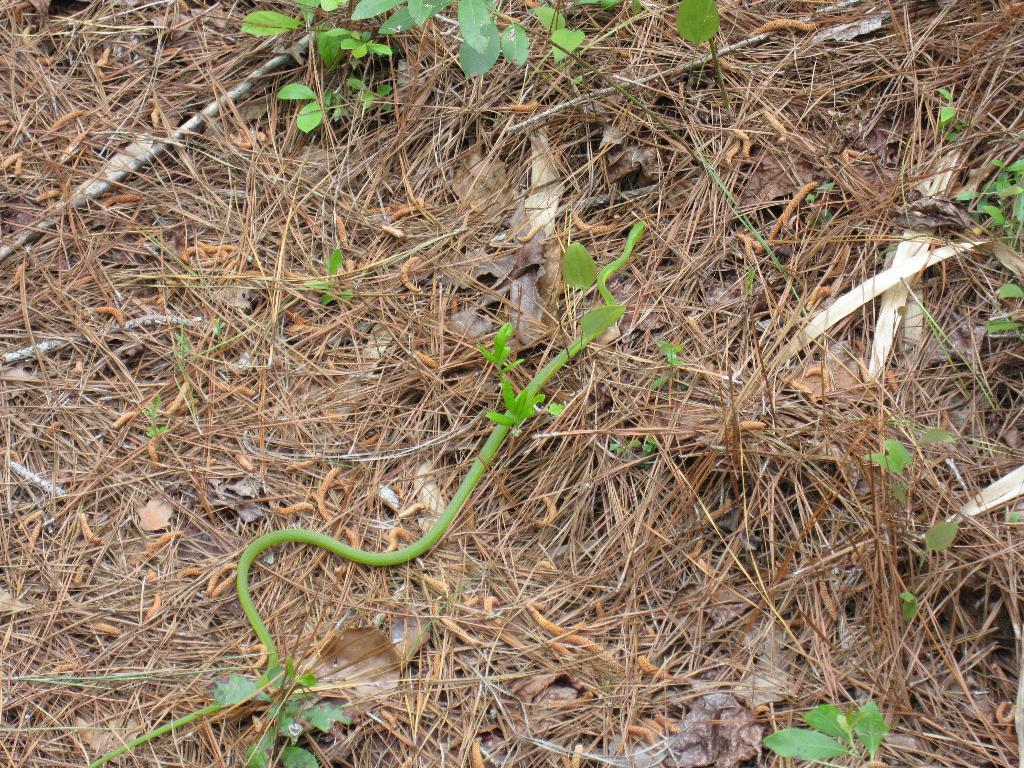What type of animal is present in the image? There is a snake in the image. What else can be seen in the image besides the snake? There are plants in the image. Can you describe the person walking on the road in the image? There is no person or road present in the image; it features a snake and plants. 